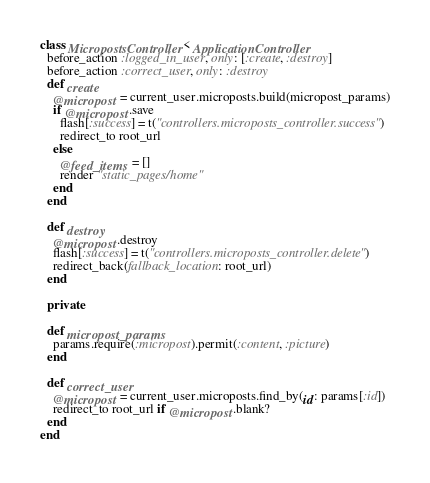Convert code to text. <code><loc_0><loc_0><loc_500><loc_500><_Ruby_>class MicropostsController < ApplicationController
  before_action :logged_in_user, only: [:create, :destroy]
  before_action :correct_user, only: :destroy
  def create
    @micropost = current_user.microposts.build(micropost_params)
    if @micropost.save
      flash[:success] = t("controllers.microposts_controller.success")
      redirect_to root_url
    else
      @feed_items = []
      render "static_pages/home"
    end
  end

  def destroy
    @micropost.destroy
    flash[:success] = t("controllers.microposts_controller.delete")
    redirect_back(fallback_location: root_url)
  end

  private

  def micropost_params
    params.require(:micropost).permit(:content, :picture)
  end

  def correct_user
    @micropost = current_user.microposts.find_by(id: params[:id])
    redirect_to root_url if @micropost.blank?
  end
end
</code> 